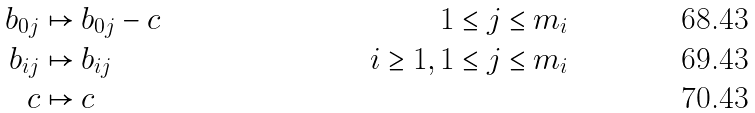Convert formula to latex. <formula><loc_0><loc_0><loc_500><loc_500>b _ { 0 j } & \mapsto b _ { 0 j } - c & \quad 1 \leq j \leq m _ { i } & \\ b _ { i j } & \mapsto b _ { i j } & \quad i \geq 1 , 1 \leq j \leq m _ { i } & \\ c & \mapsto c</formula> 